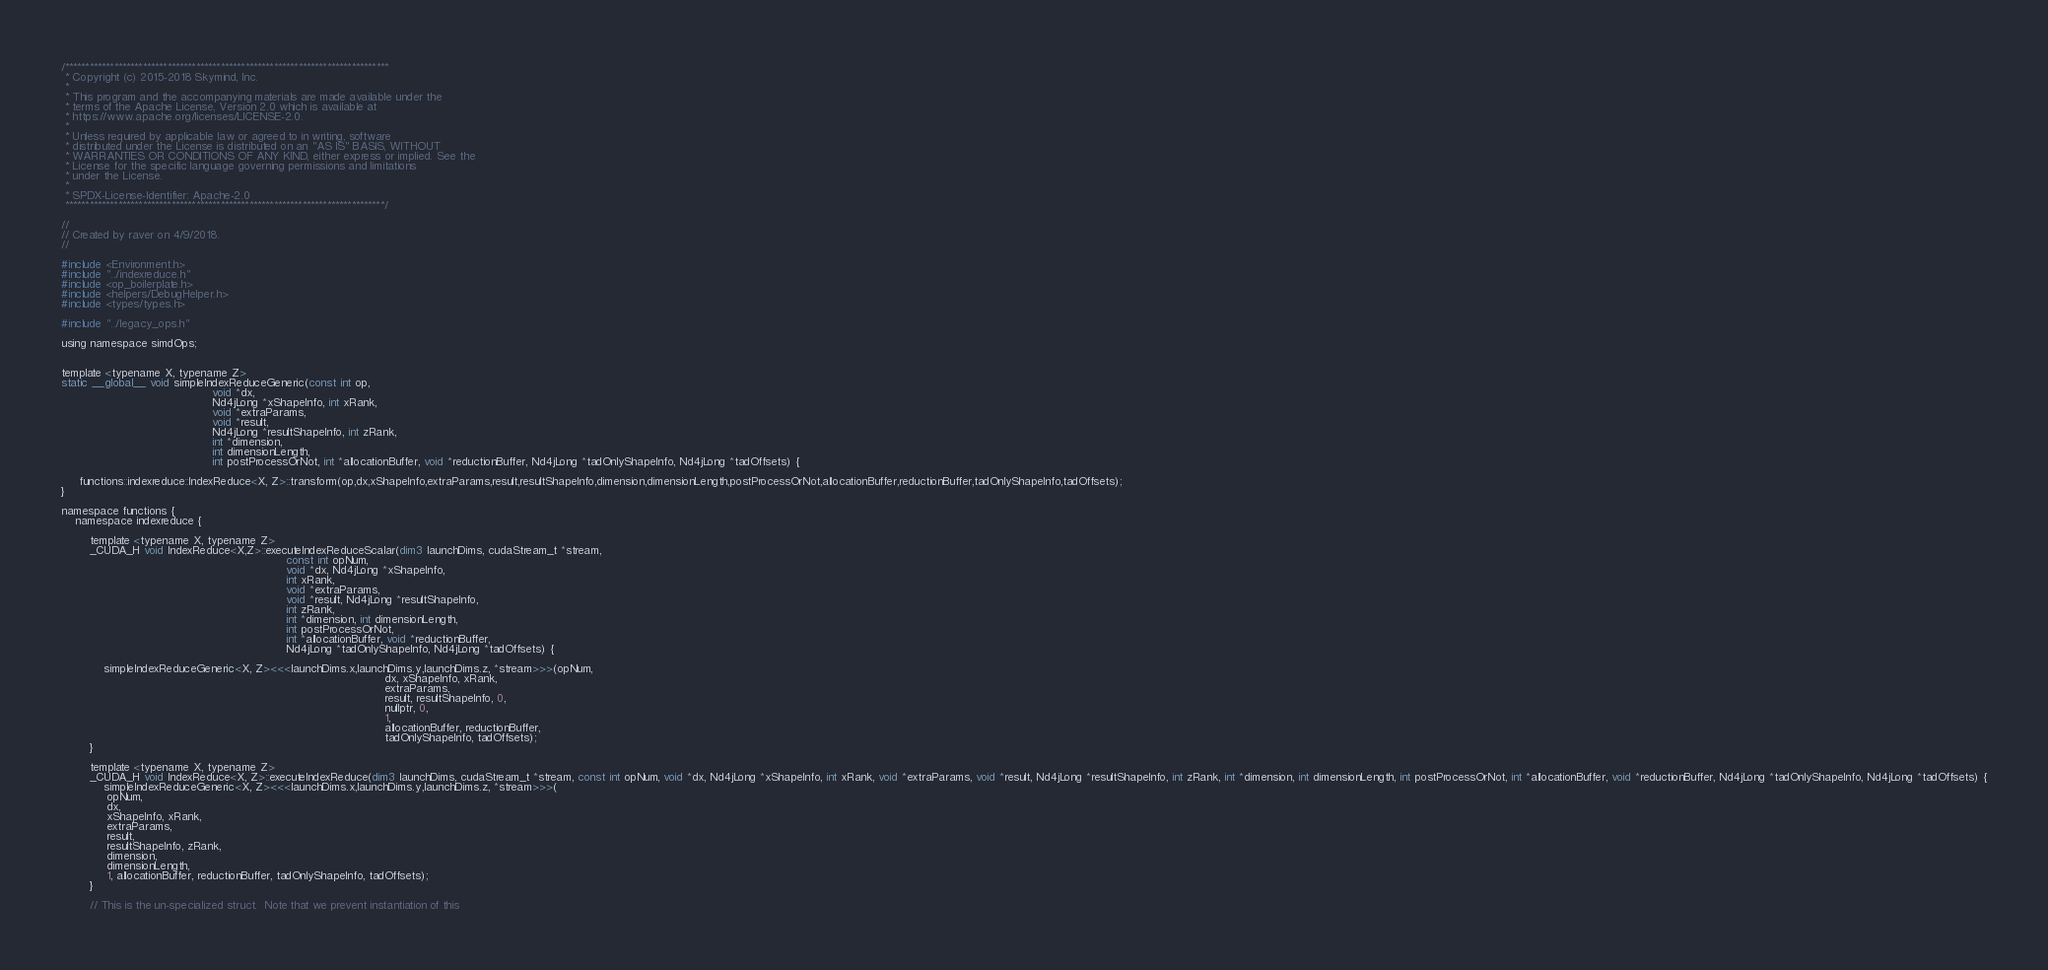Convert code to text. <code><loc_0><loc_0><loc_500><loc_500><_Cuda_>/*******************************************************************************
 * Copyright (c) 2015-2018 Skymind, Inc.
 *
 * This program and the accompanying materials are made available under the
 * terms of the Apache License, Version 2.0 which is available at
 * https://www.apache.org/licenses/LICENSE-2.0.
 *
 * Unless required by applicable law or agreed to in writing, software
 * distributed under the License is distributed on an "AS IS" BASIS, WITHOUT
 * WARRANTIES OR CONDITIONS OF ANY KIND, either express or implied. See the
 * License for the specific language governing permissions and limitations
 * under the License.
 *
 * SPDX-License-Identifier: Apache-2.0
 ******************************************************************************/

//
// Created by raver on 4/9/2018.
//

#include <Environment.h>
#include "../indexreduce.h"
#include <op_boilerplate.h>
#include <helpers/DebugHelper.h>
#include <types/types.h>

#include "../legacy_ops.h"

using namespace simdOps;


template <typename X, typename Z>
static __global__ void simpleIndexReduceGeneric(const int op,
                                           void *dx,
                                           Nd4jLong *xShapeInfo, int xRank,
                                           void *extraParams,
                                           void *result,
                                           Nd4jLong *resultShapeInfo, int zRank,
                                           int *dimension,
                                           int dimensionLength,
                                           int postProcessOrNot, int *allocationBuffer, void *reductionBuffer, Nd4jLong *tadOnlyShapeInfo, Nd4jLong *tadOffsets) {

     functions::indexreduce::IndexReduce<X, Z>::transform(op,dx,xShapeInfo,extraParams,result,resultShapeInfo,dimension,dimensionLength,postProcessOrNot,allocationBuffer,reductionBuffer,tadOnlyShapeInfo,tadOffsets);
}

namespace functions {
    namespace indexreduce {

        template <typename X, typename Z>
        _CUDA_H void IndexReduce<X,Z>::executeIndexReduceScalar(dim3 launchDims, cudaStream_t *stream,
                                                                const int opNum,
                                                                void *dx, Nd4jLong *xShapeInfo,
                                                                int xRank,
                                                                void *extraParams,
                                                                void *result, Nd4jLong *resultShapeInfo,
                                                                int zRank,
                                                                int *dimension, int dimensionLength,
                                                                int postProcessOrNot,
                                                                int *allocationBuffer, void *reductionBuffer,
                                                                Nd4jLong *tadOnlyShapeInfo, Nd4jLong *tadOffsets) {

            simpleIndexReduceGeneric<X, Z><<<launchDims.x,launchDims.y,launchDims.z, *stream>>>(opNum,
                                                                                            dx, xShapeInfo, xRank,
                                                                                            extraParams,
                                                                                            result, resultShapeInfo, 0,
                                                                                            nullptr, 0,
                                                                                            1,
                                                                                            allocationBuffer, reductionBuffer,
                                                                                            tadOnlyShapeInfo, tadOffsets);
        }

        template <typename X, typename Z>
        _CUDA_H void IndexReduce<X, Z>::executeIndexReduce(dim3 launchDims, cudaStream_t *stream, const int opNum, void *dx, Nd4jLong *xShapeInfo, int xRank, void *extraParams, void *result, Nd4jLong *resultShapeInfo, int zRank, int *dimension, int dimensionLength, int postProcessOrNot, int *allocationBuffer, void *reductionBuffer, Nd4jLong *tadOnlyShapeInfo, Nd4jLong *tadOffsets) {
            simpleIndexReduceGeneric<X, Z><<<launchDims.x,launchDims.y,launchDims.z, *stream>>>(
			 opNum,
			 dx,
			 xShapeInfo, xRank,
			 extraParams,
			 result,
			 resultShapeInfo, zRank,
			 dimension,
			 dimensionLength,
			 1, allocationBuffer, reductionBuffer, tadOnlyShapeInfo, tadOffsets);
        }

        // This is the un-specialized struct.  Note that we prevent instantiation of this</code> 